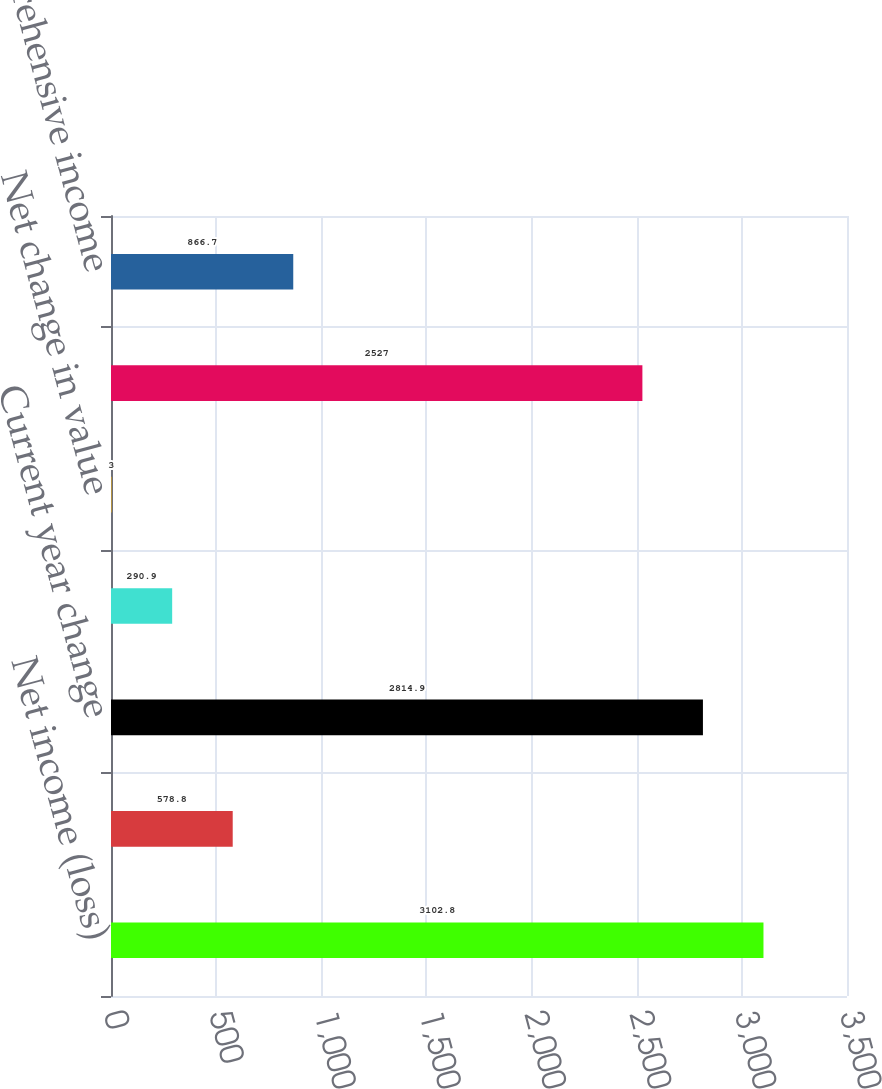<chart> <loc_0><loc_0><loc_500><loc_500><bar_chart><fcel>Net income (loss)<fcel>Amortization of actuarial loss<fcel>Current year change<fcel>Reclassification into earnings<fcel>Net change in value<fcel>Total other comprehensive<fcel>Total comprehensive income<nl><fcel>3102.8<fcel>578.8<fcel>2814.9<fcel>290.9<fcel>3<fcel>2527<fcel>866.7<nl></chart> 